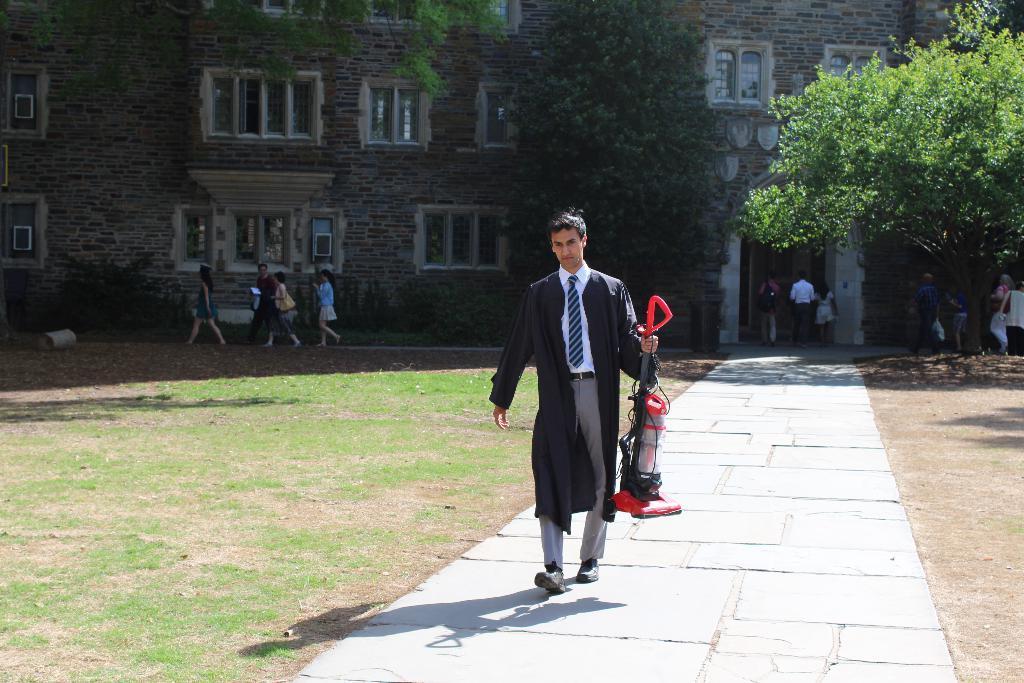How would you summarize this image in a sentence or two? In this image there is a man walking on the path. He is holding a object in his hand. On the either sides of the path there's grass on the ground. In the background there is a building. There are trees in front of the building. There are people walking near to the building. 